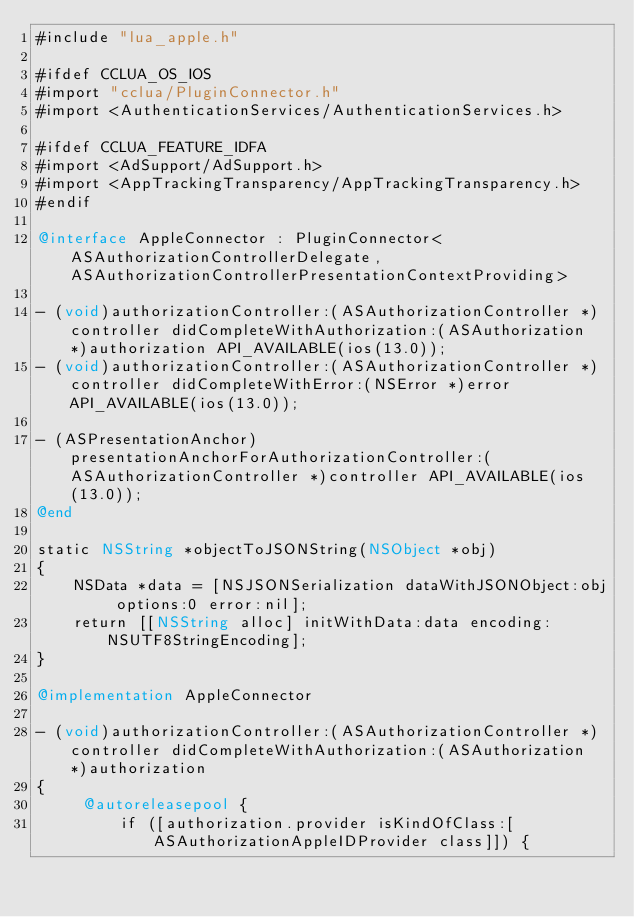<code> <loc_0><loc_0><loc_500><loc_500><_ObjectiveC_>#include "lua_apple.h"

#ifdef CCLUA_OS_IOS
#import "cclua/PluginConnector.h"
#import <AuthenticationServices/AuthenticationServices.h>

#ifdef CCLUA_FEATURE_IDFA
#import <AdSupport/AdSupport.h>
#import <AppTrackingTransparency/AppTrackingTransparency.h>
#endif

@interface AppleConnector : PluginConnector<ASAuthorizationControllerDelegate, ASAuthorizationControllerPresentationContextProviding>

- (void)authorizationController:(ASAuthorizationController *)controller didCompleteWithAuthorization:(ASAuthorization *)authorization API_AVAILABLE(ios(13.0));
- (void)authorizationController:(ASAuthorizationController *)controller didCompleteWithError:(NSError *)error API_AVAILABLE(ios(13.0));

- (ASPresentationAnchor)presentationAnchorForAuthorizationController:(ASAuthorizationController *)controller API_AVAILABLE(ios(13.0));
@end

static NSString *objectToJSONString(NSObject *obj)
{
    NSData *data = [NSJSONSerialization dataWithJSONObject:obj options:0 error:nil];
    return [[NSString alloc] initWithData:data encoding:NSUTF8StringEncoding];
}

@implementation AppleConnector

- (void)authorizationController:(ASAuthorizationController *)controller didCompleteWithAuthorization:(ASAuthorization *)authorization
{
     @autoreleasepool {
         if ([authorization.provider isKindOfClass:[ASAuthorizationAppleIDProvider class]]) {</code> 